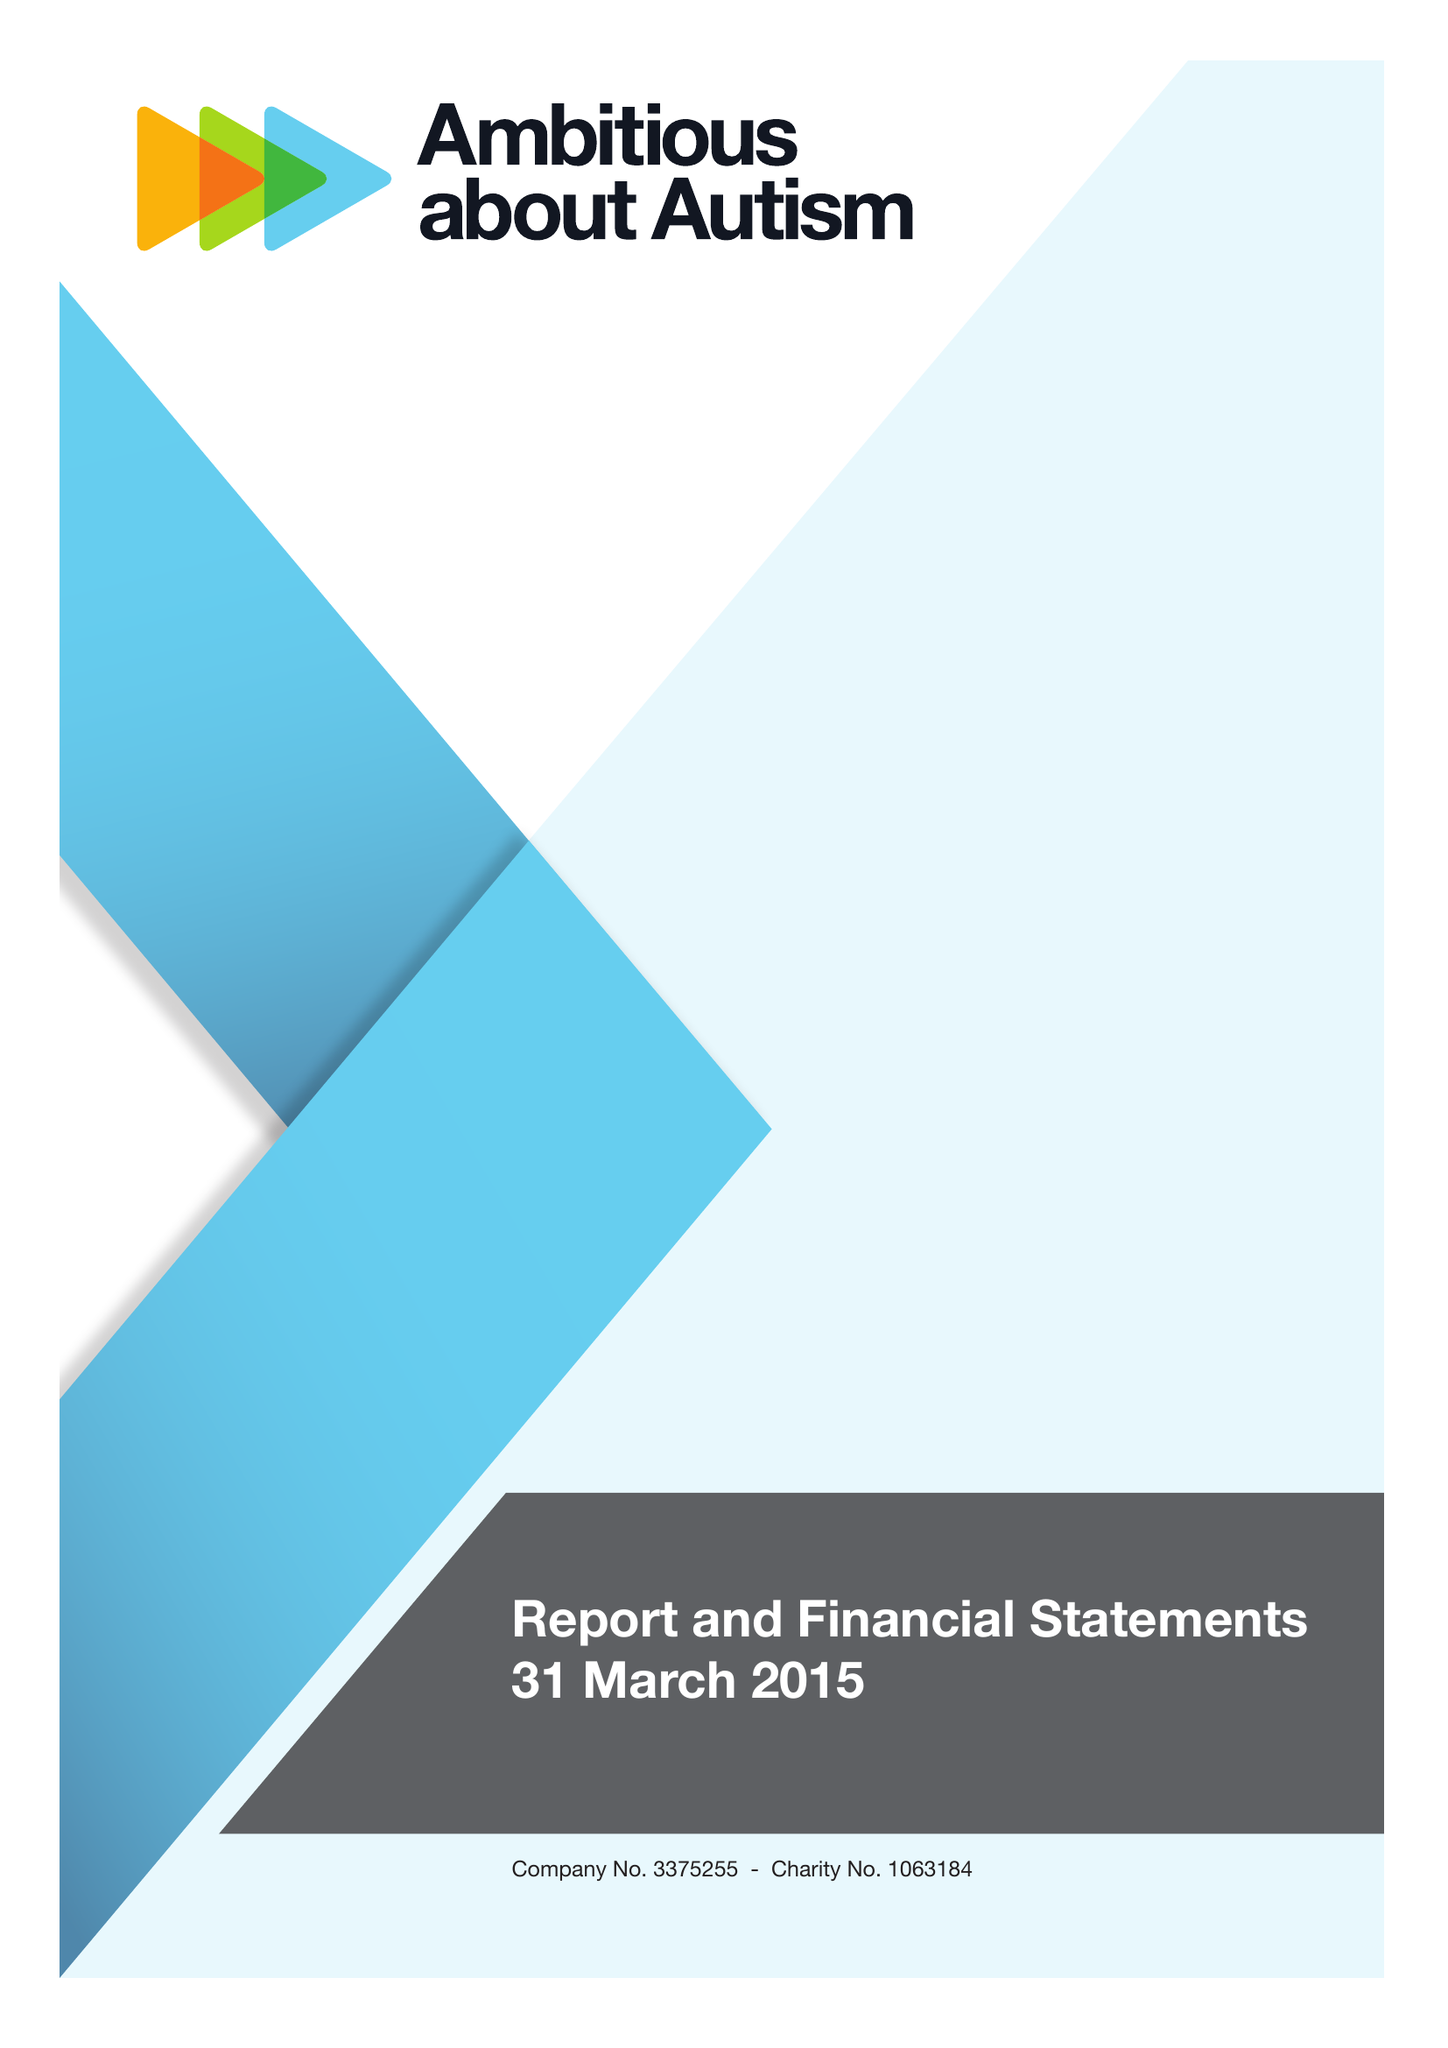What is the value for the address__postcode?
Answer the question using a single word or phrase. N10 3JA 